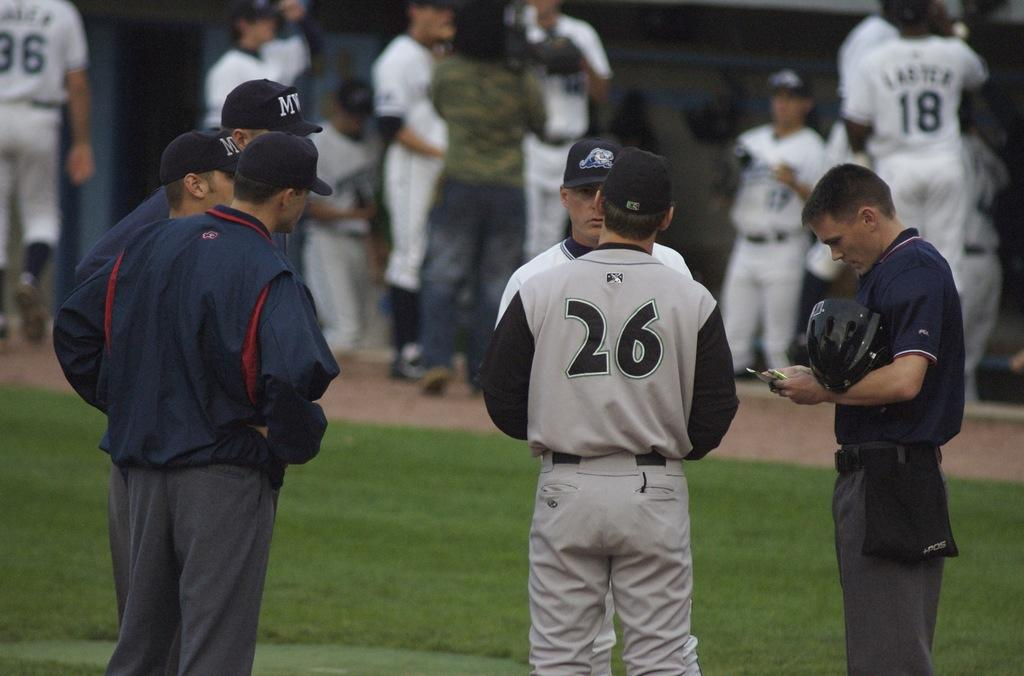<image>
Relay a brief, clear account of the picture shown. Player number twenty-six speaks to another player while on the field. 